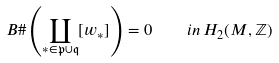<formula> <loc_0><loc_0><loc_500><loc_500>B \# \left ( \coprod _ { * \in \mathfrak { p } \cup \mathfrak { q } } [ w _ { * } ] \right ) = 0 \quad i n \, H _ { 2 } ( M , { \mathbb { Z } } )</formula> 